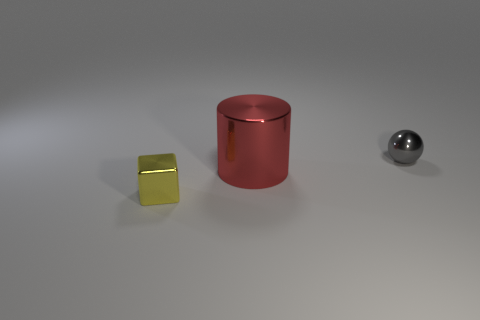Add 3 tiny yellow shiny objects. How many objects exist? 6 Subtract 1 blocks. How many blocks are left? 0 Subtract all balls. How many objects are left? 2 Subtract all balls. Subtract all metallic cylinders. How many objects are left? 1 Add 2 large red metal cylinders. How many large red metal cylinders are left? 3 Add 3 big purple shiny things. How many big purple shiny things exist? 3 Subtract 0 purple cylinders. How many objects are left? 3 Subtract all gray blocks. Subtract all yellow balls. How many blocks are left? 1 